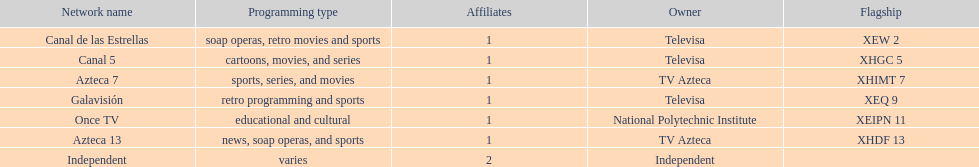Who is the only network owner listed in a consecutive order in the chart? Televisa. 